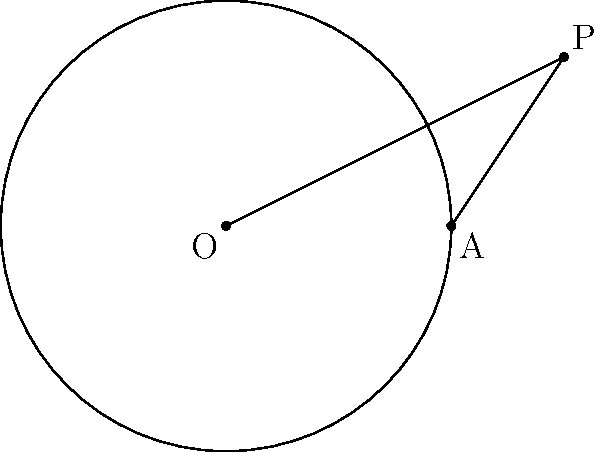In the diagram, O is the center of the circle with radius 4 units. Point P is external to the circle, and PA is tangent to the circle at point A. If the distance OP is 6 units, what is the length of the tangent line PA? Let's approach this step-by-step:

1) In a circle, a tangent line is perpendicular to the radius drawn to the point of tangency. This means that triangle OPA is a right-angled triangle with the right angle at A.

2) We can use the Pythagorean theorem in this right-angled triangle:

   $$OP^2 = OA^2 + PA^2$$

3) We know that:
   - OP = 6 (given in the question)
   - OA = 4 (radius of the circle)
   - Let PA = x (the length we're trying to find)

4) Substituting these into the Pythagorean theorem:

   $$6^2 = 4^2 + x^2$$

5) Simplify:

   $$36 = 16 + x^2$$

6) Subtract 16 from both sides:

   $$20 = x^2$$

7) Take the square root of both sides:

   $$x = \sqrt{20} = 2\sqrt{5}$$

Therefore, the length of the tangent line PA is $2\sqrt{5}$ units.
Answer: $2\sqrt{5}$ units 